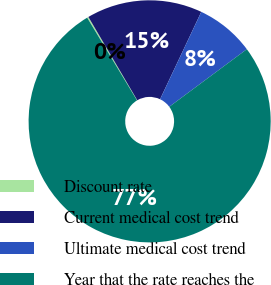<chart> <loc_0><loc_0><loc_500><loc_500><pie_chart><fcel>Discount rate<fcel>Current medical cost trend<fcel>Ultimate medical cost trend<fcel>Year that the rate reaches the<nl><fcel>0.19%<fcel>15.46%<fcel>7.82%<fcel>76.53%<nl></chart> 